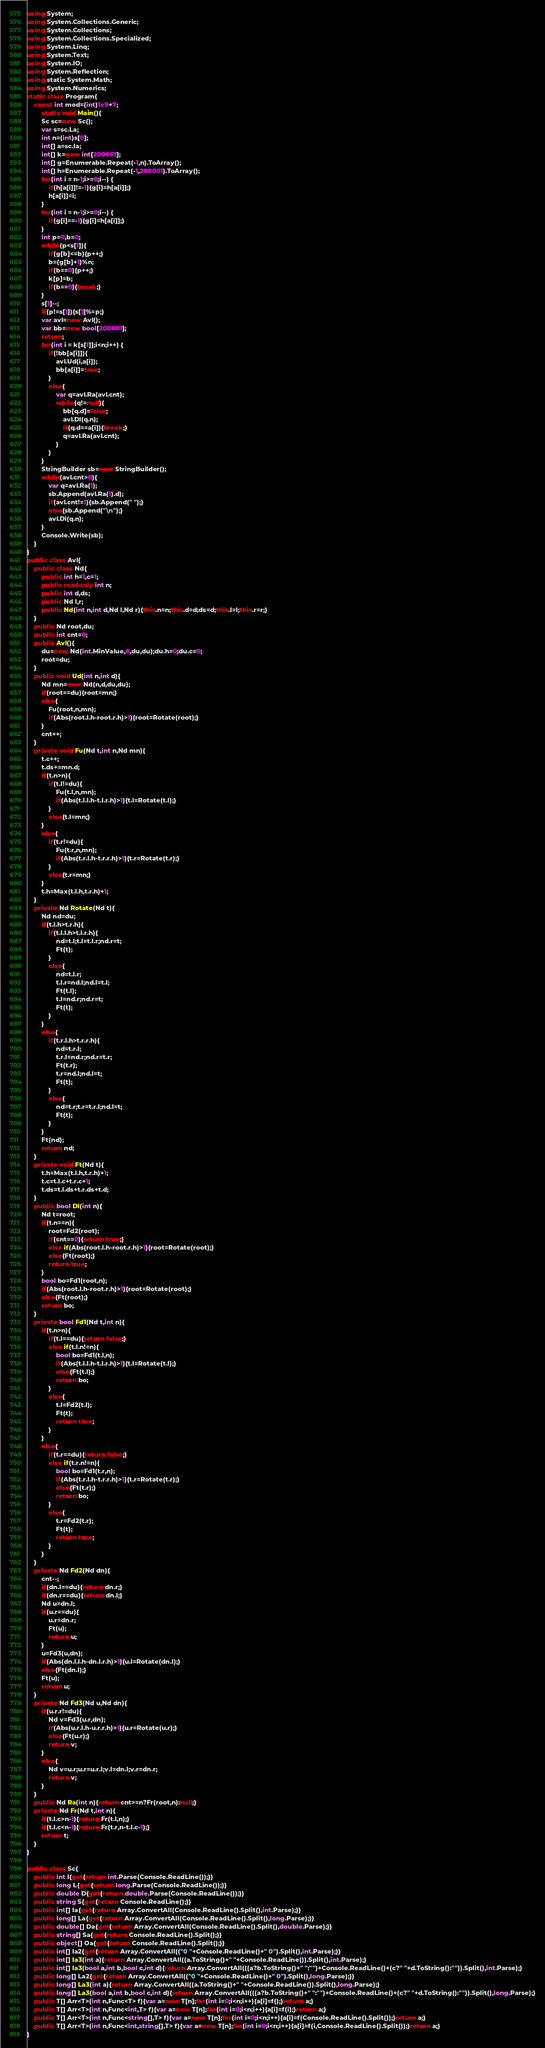Convert code to text. <code><loc_0><loc_0><loc_500><loc_500><_C#_>using System;
using System.Collections.Generic;
using System.Collections;
using System.Collections.Specialized;
using System.Linq;
using System.Text;
using System.IO;
using System.Reflection;
using static System.Math;
using System.Numerics;
static class Program{
	const int mod=(int)1e9+7;
		static void Main(){
		Sc sc=new Sc();
		var s=sc.La;
		int n=(int)s[0];
		int[] a=sc.Ia;
		int[] k=new int[200001];
		int[] g=Enumerable.Repeat(-1,n).ToArray();
		int[] h=Enumerable.Repeat(-1,200001).ToArray();
		for(int i = n-1;i>=0;i--) {
			if(h[a[i]]!=-1){g[i]=h[a[i]];}
			h[a[i]]=i;
		}
		for(int i = n-1;i>=0;i--) {
			if(g[i]==-1){g[i]=h[a[i]];}
		}
		int p=0,b=0;
		while(p<s[1]){
			if(g[b]<=b){p++;}
			b=(g[b]+1)%n;
			if(b==0){p++;}
			k[p]=b;
			if(b==0){break;}
		}
		s[1]--;
		if(p!=s[1]){s[1]%=p;}
		var avl=new Avl();
		var bb=new bool[200001];
		return;
		for(int i = k[s[1]];i<n;i++) {
			if(!bb[a[i]]){
				avl.Ud(i,a[i]);
				bb[a[i]]=true;
			}
			else{
				var q=avl.Ra(avl.cnt);
				while(q!=null){
					bb[q.d]=false;
					avl.Dl(q.n);
					if(q.d==a[i]){break;}
					q=avl.Ra(avl.cnt);
				}
			}
		}
		StringBuilder sb=new StringBuilder();
		while(avl.cnt>0){
			var q=avl.Ra(1);
			sb.Append(avl.Ra(1).d);
			if(avl.cnt!=1){sb.Append(" ");}
			else{sb.Append("\n");}
			avl.Dl(q.n);
		}
		Console.Write(sb);
	}
}
public class Avl{
	public class Nd{
		public int h=1,c=1;
		public readonly int n;
		public int d,ds;
		public Nd l,r;
		public Nd(int n,int d,Nd l,Nd r){this.n=n;this.d=d;ds=d;this.l=l;this.r=r;}
	}
	public Nd root,du;
	public int cnt=0;
	public Avl(){
		du=new Nd(int.MinValue,0,du,du);du.h=0;du.c=0;
		root=du;
	}
	public void Ud(int n,int d){
		Nd mn=new Nd(n,d,du,du);
		if(root==du){root=mn;}
		else{
			Fu(root,n,mn);
			if(Abs(root.l.h-root.r.h)>1){root=Rotate(root);}
		}
		cnt++;
	}
	private void Fu(Nd t,int n,Nd mn){
		t.c++;
		t.ds+=mn.d;
		if(t.n>n){
			if(t.l!=du){
				Fu(t.l,n,mn);
				if(Abs(t.l.l.h-t.l.r.h)>1){t.l=Rotate(t.l);}
			}
			else{t.l=mn;}
		}
		else{
			if(t.r!=du){
				Fu(t.r,n,mn);
				if(Abs(t.r.l.h-t.r.r.h)>1){t.r=Rotate(t.r);}
			}
			else{t.r=mn;}
		}
		t.h=Max(t.l.h,t.r.h)+1;
	}
	private Nd Rotate(Nd t){
		Nd nd=du;
		if(t.l.h>t.r.h){
			if(t.l.l.h>t.l.r.h){
				nd=t.l;t.l=t.l.r;nd.r=t;
				Ft(t);
			}
			else{
				nd=t.l.r;
				t.l.r=nd.l;nd.l=t.l;
				Ft(t.l);
				t.l=nd.r;nd.r=t;
				Ft(t);
			}
		}
		else{
			if(t.r.l.h>t.r.r.h){
				nd=t.r.l;
				t.r.l=nd.r;nd.r=t.r;
				Ft(t.r);
				t.r=nd.l;nd.l=t;
				Ft(t);
			}
			else{
				nd=t.r;t.r=t.r.l;nd.l=t;
				Ft(t);
			}
		}
		Ft(nd);
		return nd;
	}
	private void Ft(Nd t){
		t.h=Max(t.l.h,t.r.h)+1;
		t.c=t.l.c+t.r.c+1;
		t.ds=t.l.ds+t.r.ds+t.d;
	}
	public bool Dl(int n){
		Nd t=root;
		if(t.n==n){
			root=Fd2(root);
			if(cnt==0){return true;}
			else if(Abs(root.l.h-root.r.h)>1){root=Rotate(root);}
			else{Ft(root);}
			return true;
		}
		bool bo=Fd1(root,n);
		if(Abs(root.l.h-root.r.h)>1){root=Rotate(root);}
		else{Ft(root);}
		return bo;
	}
	private bool Fd1(Nd t,int n){
		if(t.n>n){
			if(t.l==du){return false;}
			else if(t.l.n!=n){
				bool bo=Fd1(t.l,n);
				if(Abs(t.l.l.h-t.l.r.h)>1){t.l=Rotate(t.l);}
				else{Ft(t.l);}
				return bo;
			}
			else{
				t.l=Fd2(t.l);
				Ft(t);
				return true;
			}
		}
		else{
			if(t.r==du){return false;}
			else if(t.r.n!=n){
				bool bo=Fd1(t.r,n);
				if(Abs(t.r.l.h-t.r.r.h)>1){t.r=Rotate(t.r);}
				else{Ft(t.r);}
				return bo;
			}
			else{
				t.r=Fd2(t.r);
				Ft(t);
				return true;
			}
		}
	}
	private Nd Fd2(Nd dn){
		cnt--;
		if(dn.l==du){return dn.r;}
		if(dn.r==du){return dn.l;}
		Nd u=dn.l;
		if(u.r==du){
			u.r=dn.r;
			Ft(u);
			return u;
		}
		u=Fd3(u,dn);
		if(Abs(dn.l.l.h-dn.l.r.h)>1){u.l=Rotate(dn.l);}
		else{Ft(dn.l);}
		Ft(u);
		return u;
	}
	private Nd Fd3(Nd u,Nd dn){
		if(u.r.r!=du){
			Nd v=Fd3(u.r,dn);
			if(Abs(u.r.l.h-u.r.r.h)>1){u.r=Rotate(u.r);}
			else{Ft(u.r);}
			return v;
		}
		else{
			Nd v=u.r;u.r=u.r.l;v.l=dn.l;v.r=dn.r;
			return v;
		}
	}
	public Nd Ra(int n){return cnt>=n?Fr(root,n):null;}
	private Nd Fr(Nd t,int n){
		if(t.l.c>n-1){return Fr(t.l,n);}
		if(t.l.c<n-1){return Fr(t.r,n-t.l.c-1);}
		return t;
	}
}

public class Sc{
	public int I{get{return int.Parse(Console.ReadLine());}}
	public long L{get{return long.Parse(Console.ReadLine());}}
	public double D{get{return double.Parse(Console.ReadLine());}}
	public string S{get{return Console.ReadLine();}}
	public int[] Ia{get{return Array.ConvertAll(Console.ReadLine().Split(),int.Parse);}}
	public long[] La{get{return Array.ConvertAll(Console.ReadLine().Split(),long.Parse);}}
	public double[] Da{get{return Array.ConvertAll(Console.ReadLine().Split(),double.Parse);}}
	public string[] Sa{get{return Console.ReadLine().Split();}}
	public object[] Oa{get{return Console.ReadLine().Split();}}
	public int[] Ia2{get{return Array.ConvertAll(("0 "+Console.ReadLine()+" 0").Split(),int.Parse);}}
	public int[] Ia3(int a){return Array.ConvertAll((a.ToString()+" "+Console.ReadLine()).Split(),int.Parse);}
	public int[] Ia3(bool a,int b,bool c,int d){return Array.ConvertAll(((a?b.ToString()+" ":"")+Console.ReadLine()+(c?" "+d.ToString():"")).Split(),int.Parse);}
	public long[] La2{get{return Array.ConvertAll(("0 "+Console.ReadLine()+" 0").Split(),long.Parse);}}
	public long[] La3(int a){return Array.ConvertAll((a.ToString()+" "+Console.ReadLine()).Split(),long.Parse);}
	public long[] La3(bool a,int b,bool c,int d){return Array.ConvertAll(((a?b.ToString()+" ":"")+Console.ReadLine()+(c?" "+d.ToString():"")).Split(),long.Parse);}
	public T[] Arr<T>(int n,Func<T> f){var a=new T[n];for(int i=0;i<n;i++){a[i]=f();}return a;}
	public T[] Arr<T>(int n,Func<int,T> f){var a=new T[n];for(int i=0;i<n;i++){a[i]=f(i);}return a;}
	public T[] Arr<T>(int n,Func<string[],T> f){var a=new T[n];for(int i=0;i<n;i++){a[i]=f(Console.ReadLine().Split());}return a;}
	public T[] Arr<T>(int n,Func<int,string[],T> f){var a=new T[n];for(int i=0;i<n;i++){a[i]=f(i,Console.ReadLine().Split());}return a;}
}</code> 